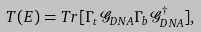Convert formula to latex. <formula><loc_0><loc_0><loc_500><loc_500>T ( E ) = T r [ \Gamma _ { t } \mathcal { G } _ { D N A } \Gamma _ { b } \mathcal { G } _ { D N A } ^ { \dagger } ] ,</formula> 